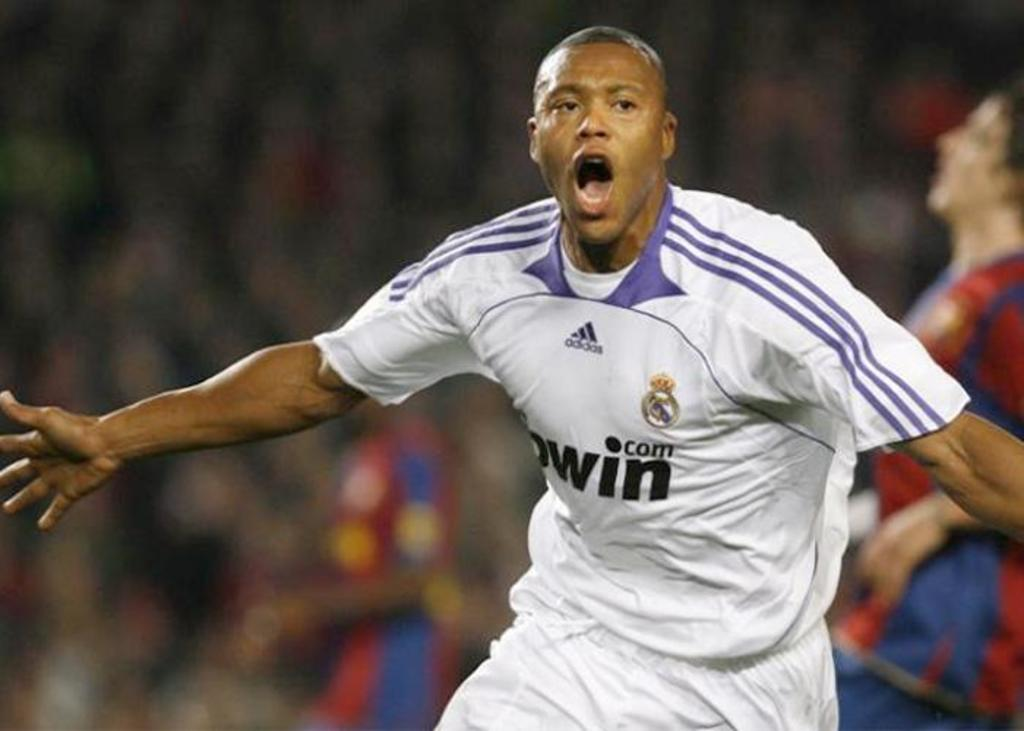How many individuals are present in the image? There are a few people in the image. Can you describe the background of the image? The background of the image is blurred. How many ants can be seen crawling on the people in the image? There are no ants visible in the image. What type of expansion is taking place in the image? There is no expansion taking place in the image; it is a still image of people and a blurred background. 